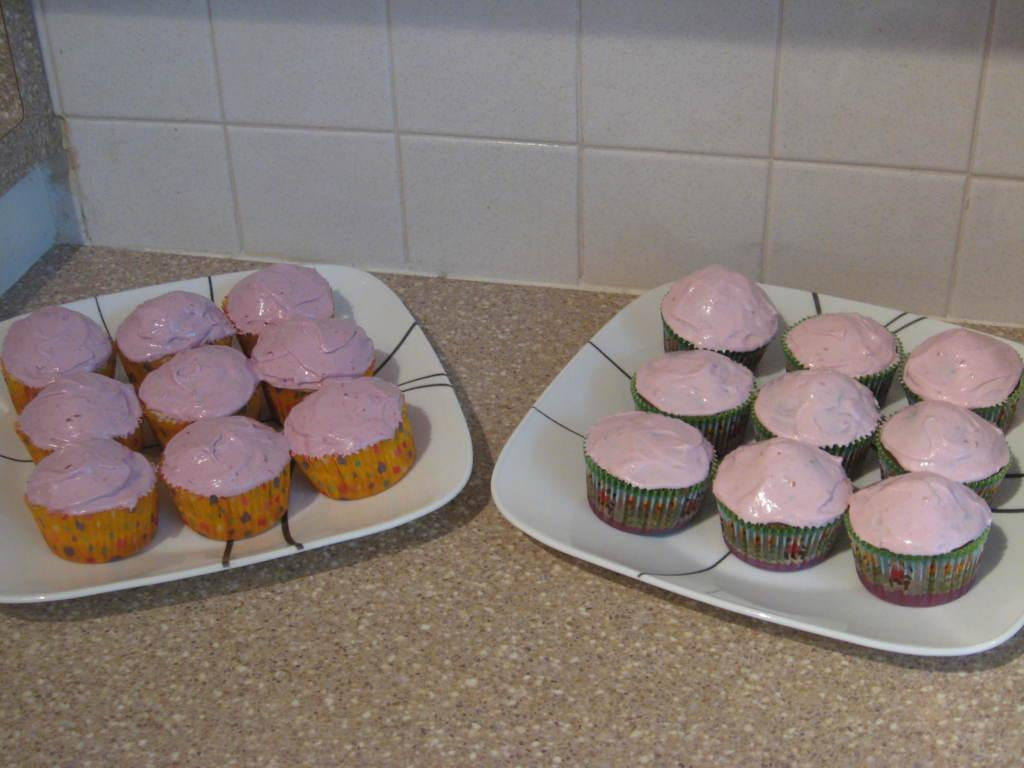What type of food can be seen in the foreground of the image? There are pancakes on the platters in the foreground of the image. Where are the pancakes located? The pancakes are on the floor. What can be seen in the background of the image? There is a wall visible in the background of the image. What type of rock can be seen in the image? There is no rock present in the image; it features pancakes on the floor and a wall in the background. 